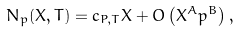Convert formula to latex. <formula><loc_0><loc_0><loc_500><loc_500>N _ { p } ( X , T ) = c _ { P , T } X + O \left ( X ^ { A } p ^ { B } \right ) ,</formula> 